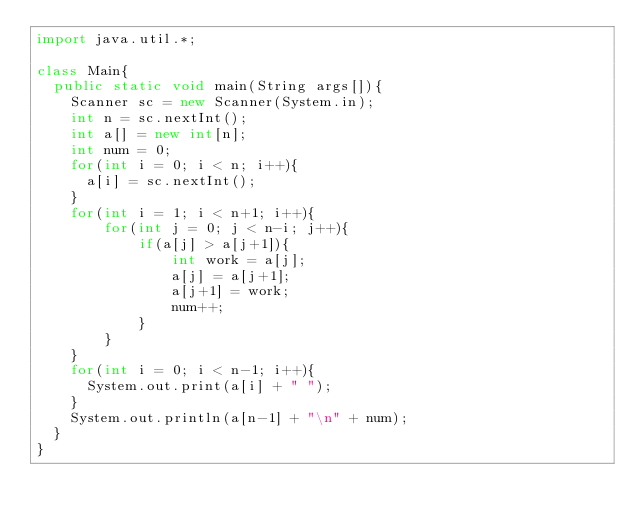<code> <loc_0><loc_0><loc_500><loc_500><_Java_>import java.util.*;

class Main{
  public static void main(String args[]){
    Scanner sc = new Scanner(System.in);
    int n = sc.nextInt();
    int a[] = new int[n];
    int num = 0;
    for(int i = 0; i < n; i++){
      a[i] = sc.nextInt();
    }
	for(int i = 1; i < n+1; i++){
    	for(int j = 0; j < n-i; j++){
      		if(a[j] > a[j+1]){
        		int work = a[j];
        		a[j] = a[j+1];
        		a[j+1] = work;
       			num++;
      		}
    	}
	}
    for(int i = 0; i < n-1; i++){
      System.out.print(a[i] + " ");
    }
    System.out.println(a[n-1] + "\n" + num);
  }
}

</code> 